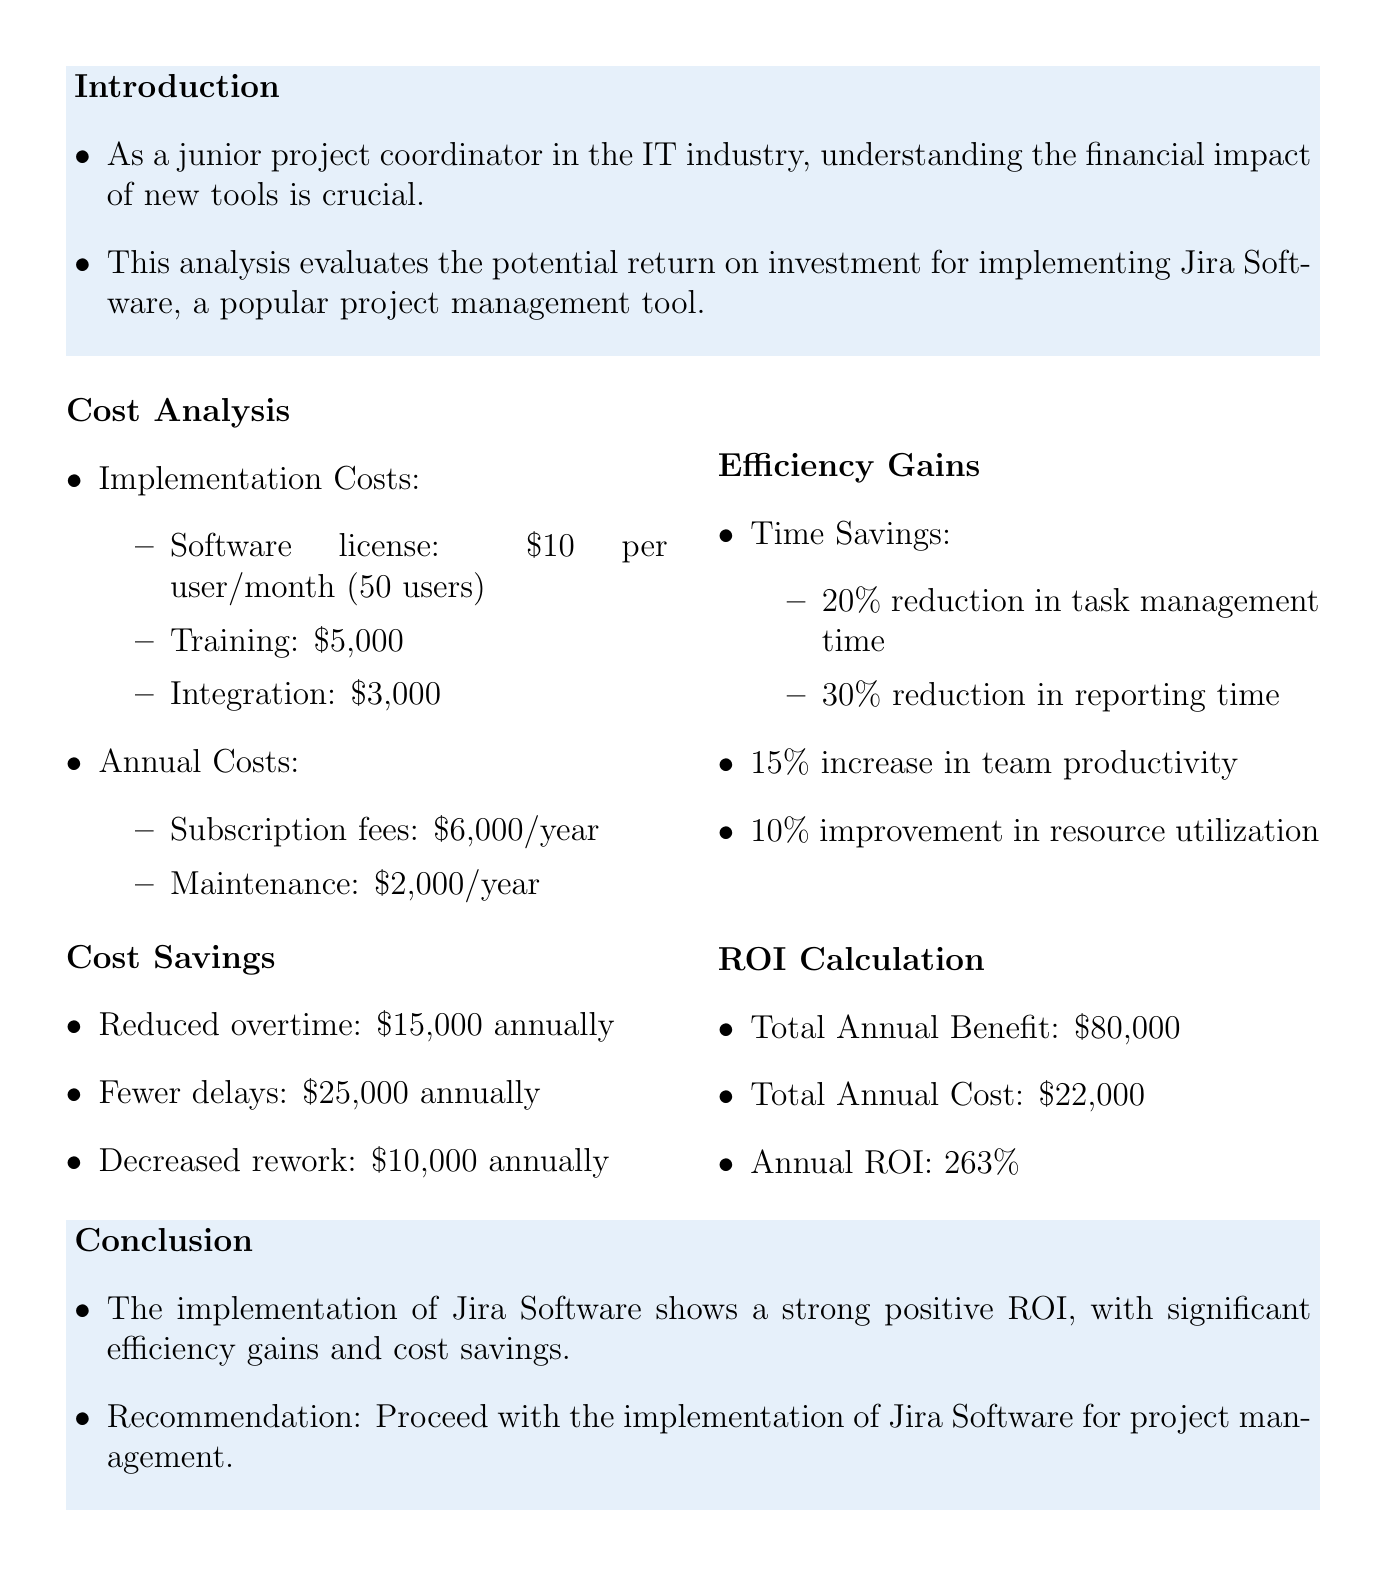What is the title of the project? The title of the project is found in the header section of the document.
Answer: ROI Analysis: Jira Software Implementation What is the implementation training cost? The training cost is listed under implementation costs in the cost analysis section.
Answer: $5,000 What is the annual subscription fee for the software? The annual subscription fee is situated in the annual costs section of the cost analysis.
Answer: $6,000 per year What percentage of time savings is reported for task management? This information is given in the efficiency gains section regarding time savings for task management.
Answer: 20% What is the total annual benefit calculated in the ROI calculation? The total annual benefit combines cost savings and efficiency gains mentioned in the ROI calculation section.
Answer: $80,000 What percentage increase in team productivity is stated? The increase in team productivity can be found within the efficiency gains section that discusses collaboration.
Answer: 15% What is the annual ROI percentage? The annual ROI is explicitly stated in the ROI calculation section of the document.
Answer: 263% Which system is recommended for implementation based on the conclusion? The conclusion section recommends a specific project management tool.
Answer: Jira Software What is the total annual cost of implementing the software? The total annual cost is detailed in the ROI calculation section of the document.
Answer: $22,000 